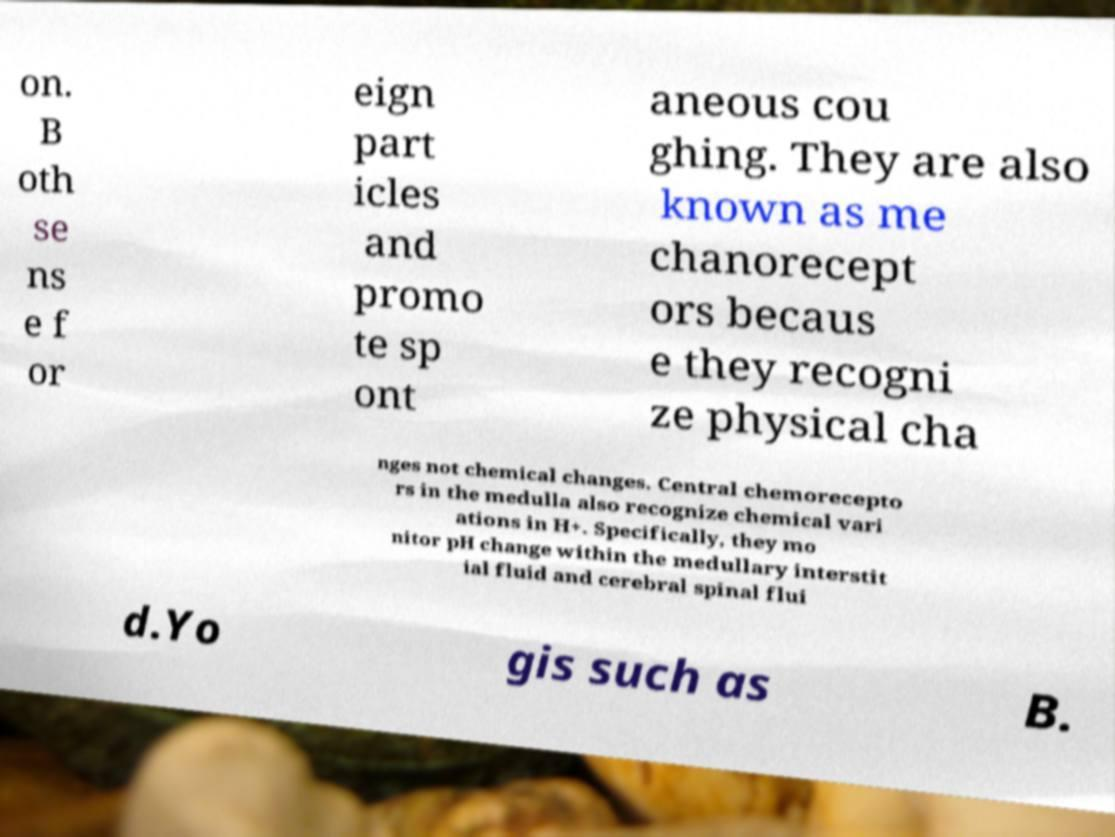Please read and relay the text visible in this image. What does it say? on. B oth se ns e f or eign part icles and promo te sp ont aneous cou ghing. They are also known as me chanorecept ors becaus e they recogni ze physical cha nges not chemical changes. Central chemorecepto rs in the medulla also recognize chemical vari ations in H+. Specifically, they mo nitor pH change within the medullary interstit ial fluid and cerebral spinal flui d.Yo gis such as B. 